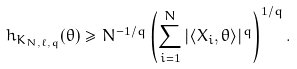<formula> <loc_0><loc_0><loc_500><loc_500>h _ { K _ { N , \ell , q } } ( \theta ) \geq N ^ { - 1 / q } \left ( \sum _ { i = 1 } ^ { N } | \langle X _ { i } , \theta \rangle | ^ { q } \right ) ^ { 1 / q } .</formula> 